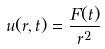Convert formula to latex. <formula><loc_0><loc_0><loc_500><loc_500>u ( r , t ) = \frac { F ( t ) } { r ^ { 2 } }</formula> 